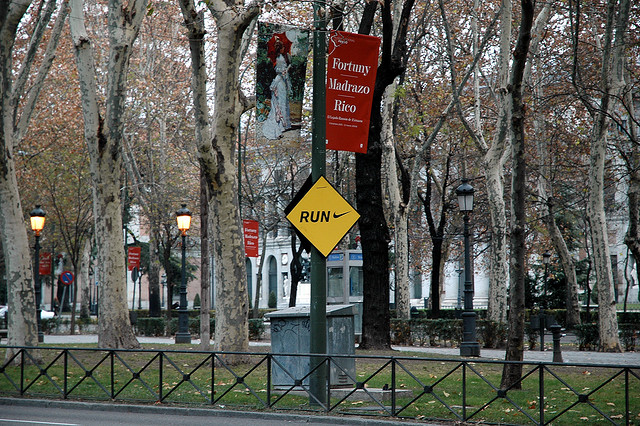<image>What vehicle is on the sign? There is no vehicle on the sign. What vehicle is on the sign? There is no vehicle on the sign. 